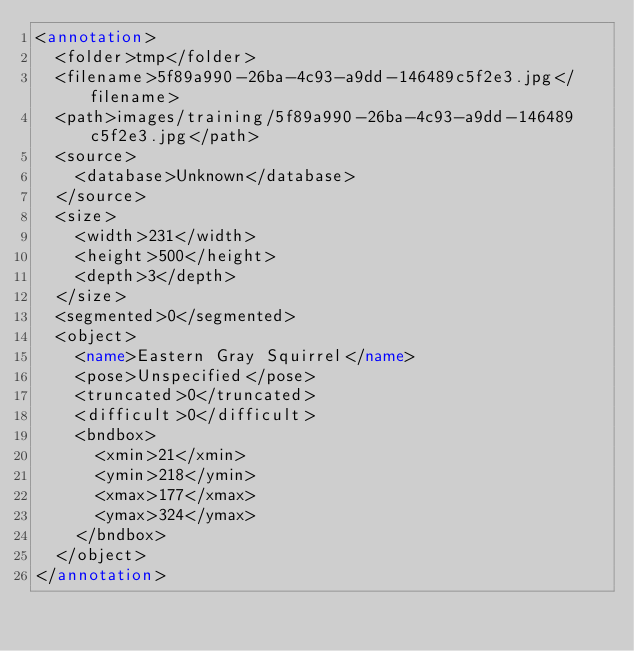<code> <loc_0><loc_0><loc_500><loc_500><_XML_><annotation>
	<folder>tmp</folder>
	<filename>5f89a990-26ba-4c93-a9dd-146489c5f2e3.jpg</filename>
	<path>images/training/5f89a990-26ba-4c93-a9dd-146489c5f2e3.jpg</path>
	<source>
		<database>Unknown</database>
	</source>
	<size>
		<width>231</width>
		<height>500</height>
		<depth>3</depth>
	</size>
	<segmented>0</segmented>
	<object>
		<name>Eastern Gray Squirrel</name>
		<pose>Unspecified</pose>
		<truncated>0</truncated>
		<difficult>0</difficult>
		<bndbox>
			<xmin>21</xmin>
			<ymin>218</ymin>
			<xmax>177</xmax>
			<ymax>324</ymax>
		</bndbox>
	</object>
</annotation>
</code> 